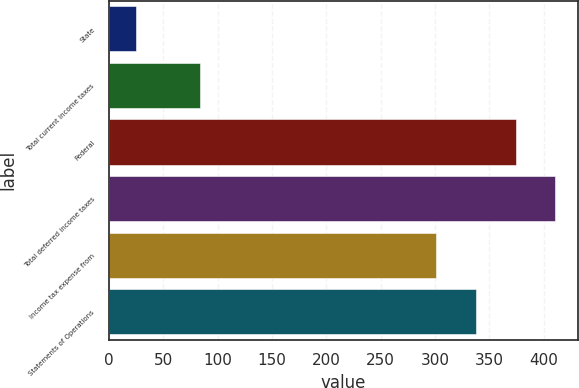<chart> <loc_0><loc_0><loc_500><loc_500><bar_chart><fcel>State<fcel>Total current income taxes<fcel>Federal<fcel>Total deferred income taxes<fcel>Income tax expense from<fcel>Statements of Operations<nl><fcel>25<fcel>84<fcel>374<fcel>410.5<fcel>301<fcel>337.5<nl></chart> 